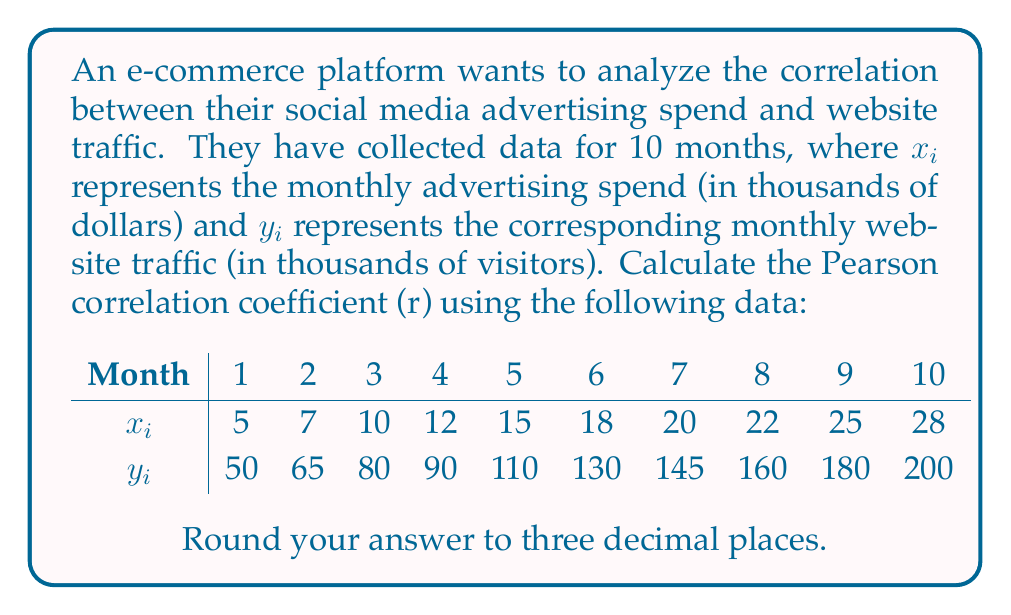Solve this math problem. To calculate the Pearson correlation coefficient (r), we'll use the formula:

$$r = \frac{n\sum{x_iy_i} - \sum{x_i}\sum{y_i}}{\sqrt{[n\sum{x_i^2} - (\sum{x_i})^2][n\sum{y_i^2} - (\sum{y_i})^2]}}$$

where $n$ is the number of data points.

Step 1: Calculate the necessary sums:
$n = 10$
$\sum{x_i} = 162$
$\sum{y_i} = 1210$
$\sum{x_i^2} = 3,878$
$\sum{y_i^2} = 172,700$
$\sum{x_iy_i} = 23,740$

Step 2: Calculate the numerator:
$n\sum{x_iy_i} - \sum{x_i}\sum{y_i} = 10(23,740) - 162(1210) = 41,180$

Step 3: Calculate the denominator:
$\sqrt{[n\sum{x_i^2} - (\sum{x_i})^2][n\sum{y_i^2} - (\sum{y_i})^2]}$
$= \sqrt{[10(3,878) - 162^2][10(172,700) - 1210^2]}$
$= \sqrt{[38,780 - 26,244][1,727,000 - 1,464,100]}$
$= \sqrt{12,536 \times 262,900}$
$= \sqrt{3,295,710,400}$
$= 57,407.94$

Step 4: Calculate r:
$r = \frac{41,180}{57,407.94} = 0.7173$

Step 5: Round to three decimal places:
$r ≈ 0.717$
Answer: The Pearson correlation coefficient (r) between social media advertising spend and website traffic for the e-commerce platform is approximately 0.717. 